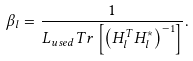Convert formula to latex. <formula><loc_0><loc_0><loc_500><loc_500>\beta _ { l } = \frac { 1 } { L _ { u s e d } T r \left [ \left ( H _ { l } ^ { T } H _ { l } ^ { * } \right ) ^ { - 1 } \right ] } .</formula> 